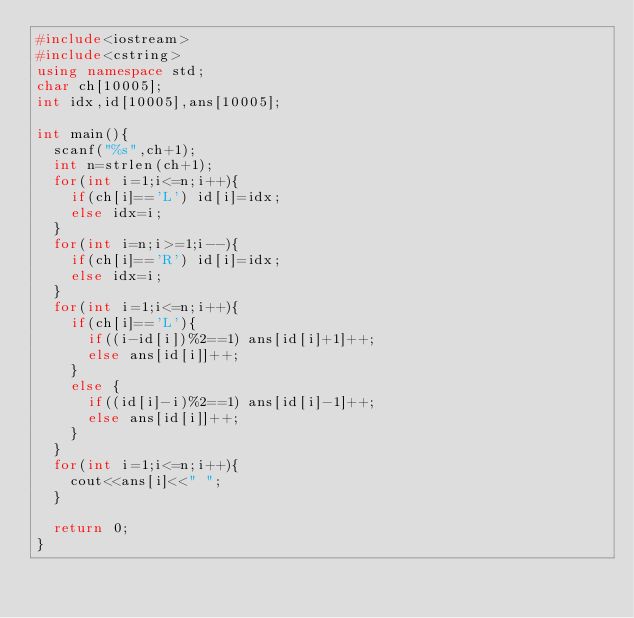Convert code to text. <code><loc_0><loc_0><loc_500><loc_500><_C++_>#include<iostream>
#include<cstring>
using namespace std;
char ch[10005];
int idx,id[10005],ans[10005];

int main(){
	scanf("%s",ch+1);
	int n=strlen(ch+1);
	for(int i=1;i<=n;i++){
		if(ch[i]=='L') id[i]=idx;
		else idx=i;
	}
	for(int i=n;i>=1;i--){
		if(ch[i]=='R') id[i]=idx;
		else idx=i;
	}
	for(int i=1;i<=n;i++){
		if(ch[i]=='L'){
			if((i-id[i])%2==1) ans[id[i]+1]++;
			else ans[id[i]]++; 
		}
		else {
			if((id[i]-i)%2==1) ans[id[i]-1]++;
			else ans[id[i]]++;
		}
	}
	for(int i=1;i<=n;i++){
		cout<<ans[i]<<" ";
	}
	
	return 0;
}</code> 